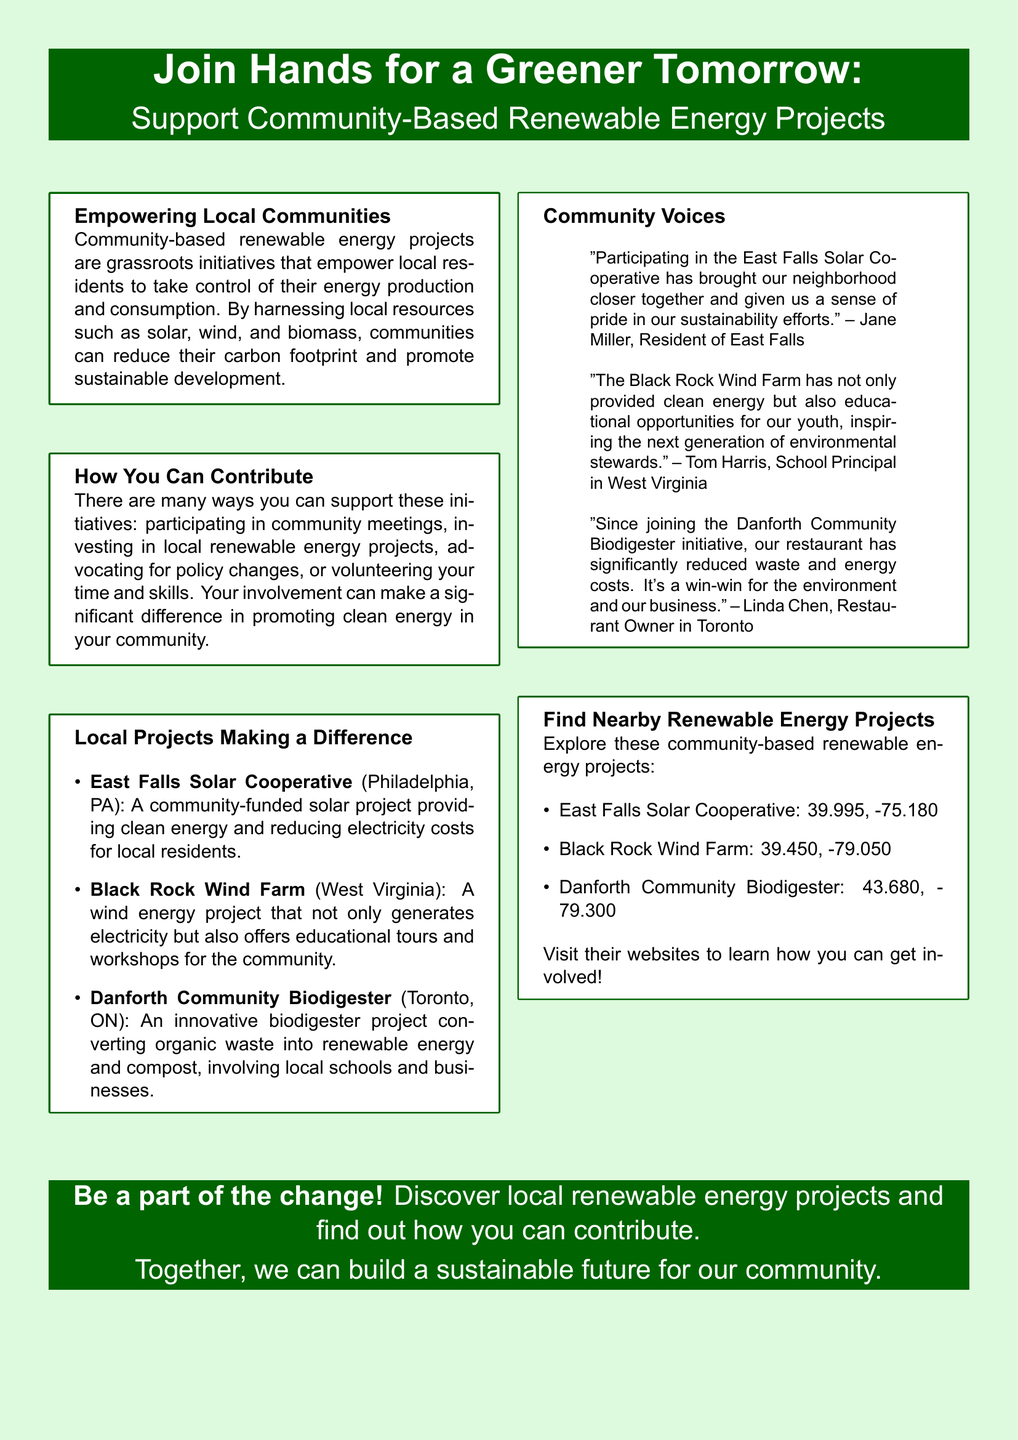What is the title of the advertisement? The title of the advertisement emphasizes community involvement in renewable energy projects, stating "Join Hands for a Greener Tomorrow: Support Community-Based Renewable Energy Projects."
Answer: Join Hands for a Greener Tomorrow: Support Community-Based Renewable Energy Projects Which city hosts the East Falls Solar Cooperative? The document specifies that the East Falls Solar Cooperative is located in Philadelphia, PA.
Answer: Philadelphia, PA What type of energy does the Black Rock Wind Farm generate? The document mentions that the Black Rock Wind Farm generates wind energy.
Answer: Wind energy How can individuals support community-based renewable energy projects? The document outlines various ways to support these projects, including participating in community meetings and investing in local projects.
Answer: Participating in community meetings, investing in local projects Who expressed pride in the East Falls Solar Cooperative? The document includes a quote from Jane Miller, who is a resident of East Falls.
Answer: Jane Miller What is the purpose of the Danforth Community Biodigester? The document describes the Danforth Community Biodigester as a project that converts organic waste into renewable energy and compost.
Answer: Convert organic waste into renewable energy and compost How many community quotes are included in the advertisement? The document features three community quotes from different individuals involved in local projects.
Answer: Three What is the latitude of the East Falls Solar Cooperative? The document provides the coordinates for the East Falls Solar Cooperative, with a latitude of 39.995.
Answer: 39.995 